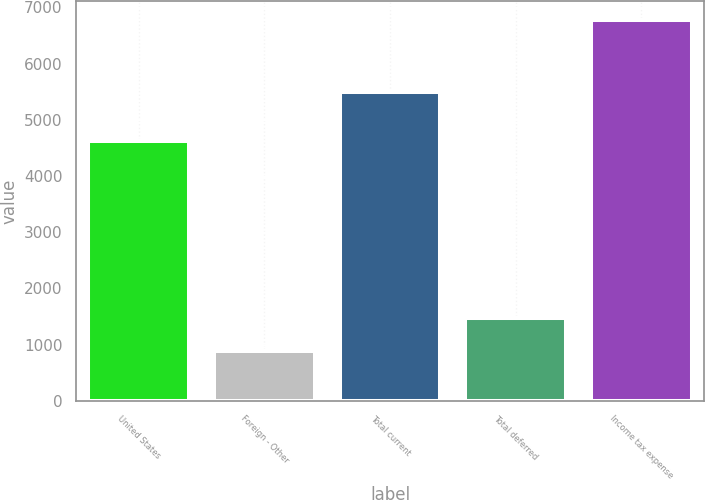<chart> <loc_0><loc_0><loc_500><loc_500><bar_chart><fcel>United States<fcel>Foreign - Other<fcel>Total current<fcel>Total deferred<fcel>Income tax expense<nl><fcel>4621<fcel>882<fcel>5503<fcel>1471<fcel>6772<nl></chart> 